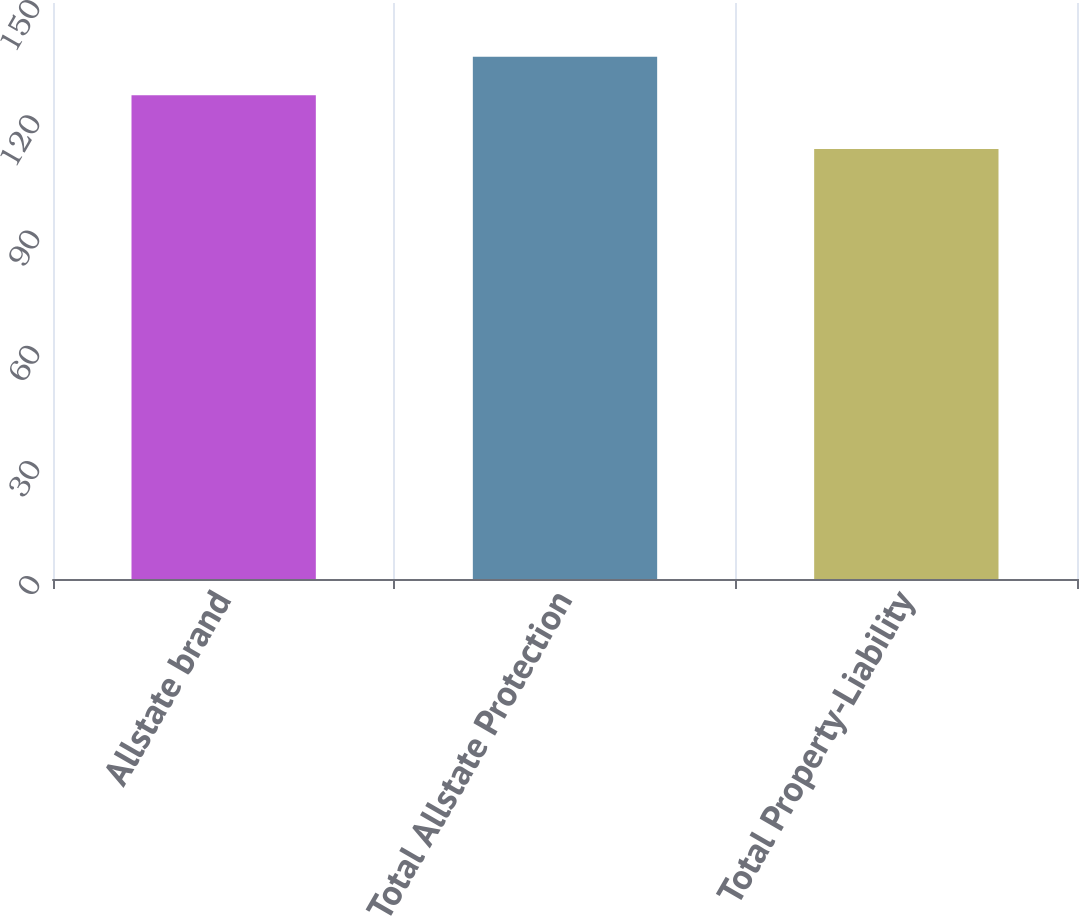Convert chart. <chart><loc_0><loc_0><loc_500><loc_500><bar_chart><fcel>Allstate brand<fcel>Total Allstate Protection<fcel>Total Property-Liability<nl><fcel>126<fcel>136<fcel>112<nl></chart> 